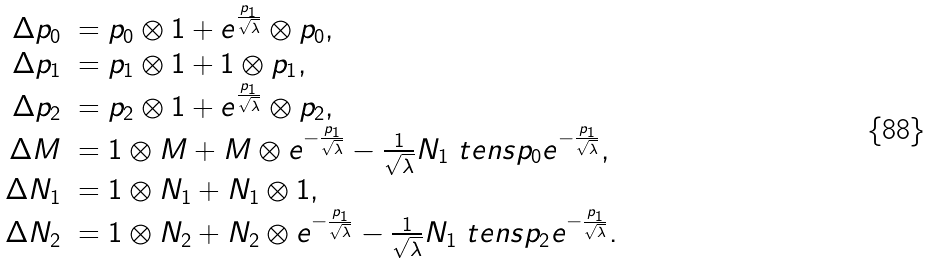<formula> <loc_0><loc_0><loc_500><loc_500>\begin{array} { r l } \Delta p _ { 0 } & = p _ { 0 } \otimes 1 + e ^ { \frac { p _ { 1 } } { \sqrt { \lambda } } } \otimes p _ { 0 } , \\ \Delta p _ { 1 } & = p _ { 1 } \otimes 1 + 1 \otimes p _ { 1 } , \\ \Delta p _ { 2 } & = p _ { 2 } \otimes 1 + e ^ { \frac { p _ { 1 } } { \sqrt { \lambda } } } \otimes p _ { 2 } , \\ \Delta M & = 1 \otimes M + M \otimes e ^ { - \frac { p _ { 1 } } { \sqrt { \lambda } } } - \frac { 1 } { \sqrt { \lambda } } N _ { 1 } \ t e n s p _ { 0 } e ^ { - \frac { p _ { 1 } } { \sqrt { \lambda } } } , \\ \Delta N _ { 1 } & = 1 \otimes N _ { 1 } + N _ { 1 } \otimes 1 , \\ \Delta N _ { 2 } & = 1 \otimes N _ { 2 } + N _ { 2 } \otimes e ^ { - \frac { p _ { 1 } } { \sqrt { \lambda } } } - \frac { 1 } { \sqrt { \lambda } } N _ { 1 } \ t e n s p _ { 2 } e ^ { - \frac { p _ { 1 } } { \sqrt { \lambda } } } . \end{array}</formula> 